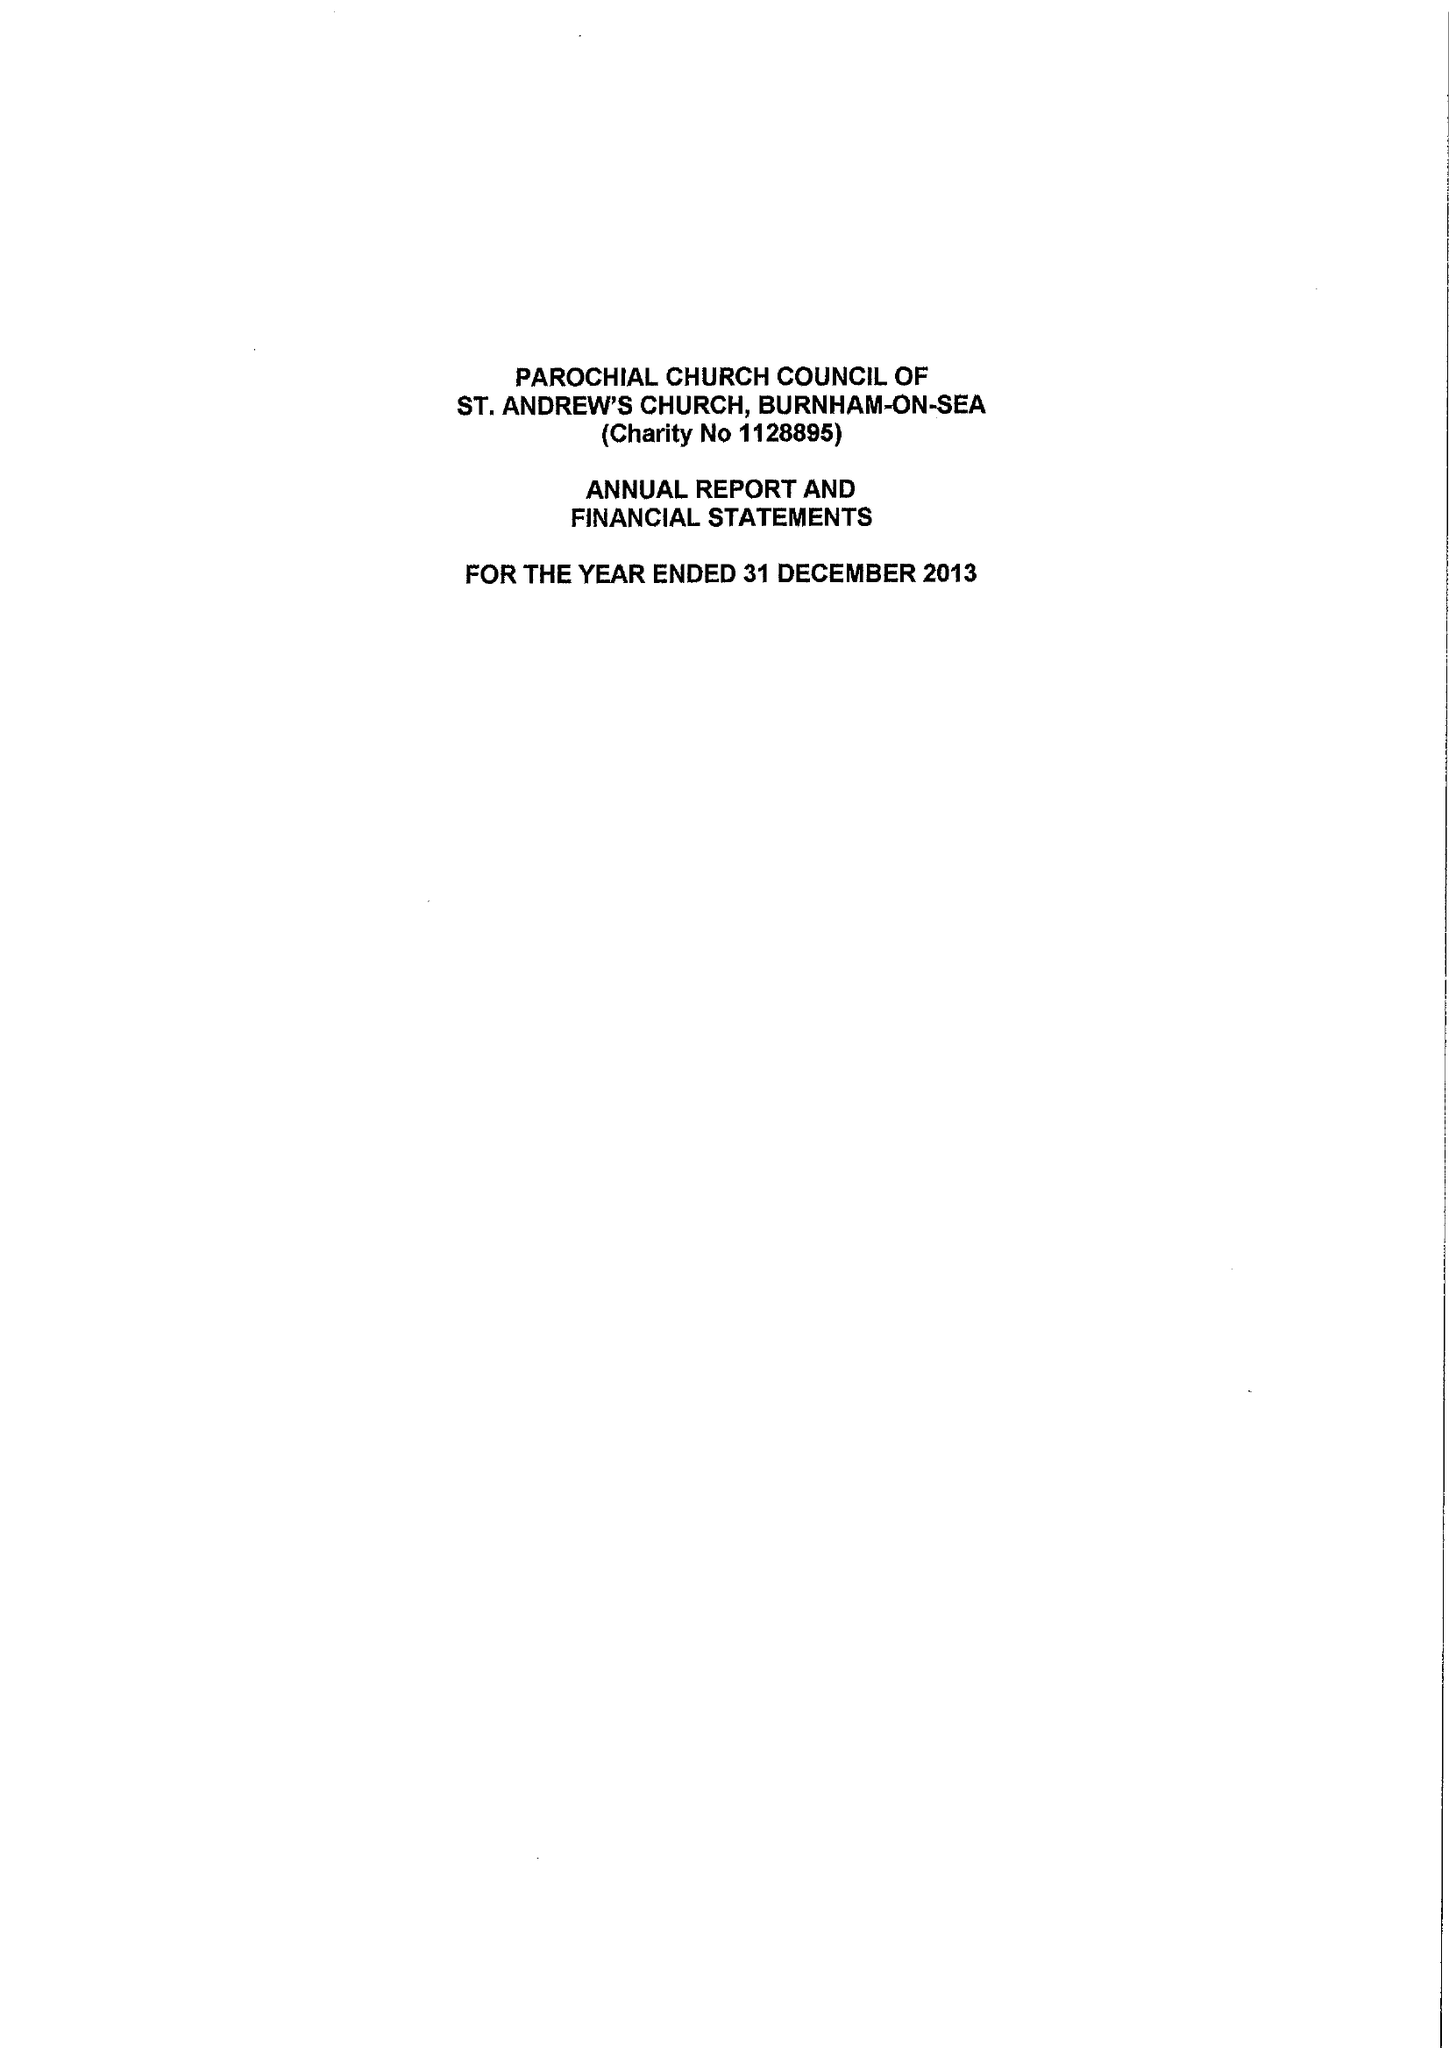What is the value for the spending_annually_in_british_pounds?
Answer the question using a single word or phrase. 109448.00 